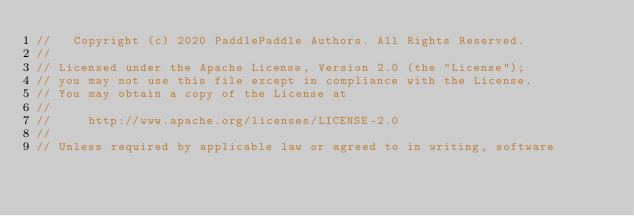<code> <loc_0><loc_0><loc_500><loc_500><_Cuda_>//   Copyright (c) 2020 PaddlePaddle Authors. All Rights Reserved.
//
// Licensed under the Apache License, Version 2.0 (the "License");
// you may not use this file except in compliance with the License.
// You may obtain a copy of the License at
//
//     http://www.apache.org/licenses/LICENSE-2.0
//
// Unless required by applicable law or agreed to in writing, software</code> 